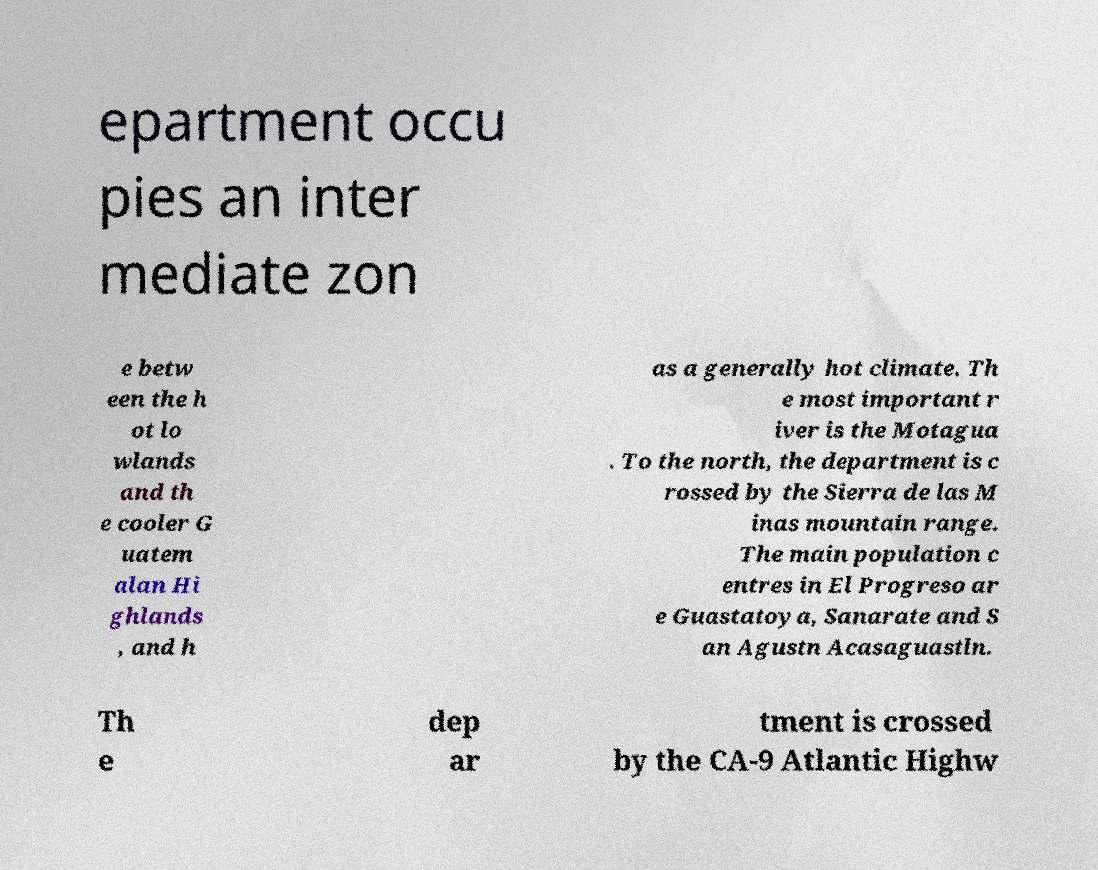For documentation purposes, I need the text within this image transcribed. Could you provide that? epartment occu pies an inter mediate zon e betw een the h ot lo wlands and th e cooler G uatem alan Hi ghlands , and h as a generally hot climate. Th e most important r iver is the Motagua . To the north, the department is c rossed by the Sierra de las M inas mountain range. The main population c entres in El Progreso ar e Guastatoya, Sanarate and S an Agustn Acasaguastln. Th e dep ar tment is crossed by the CA-9 Atlantic Highw 